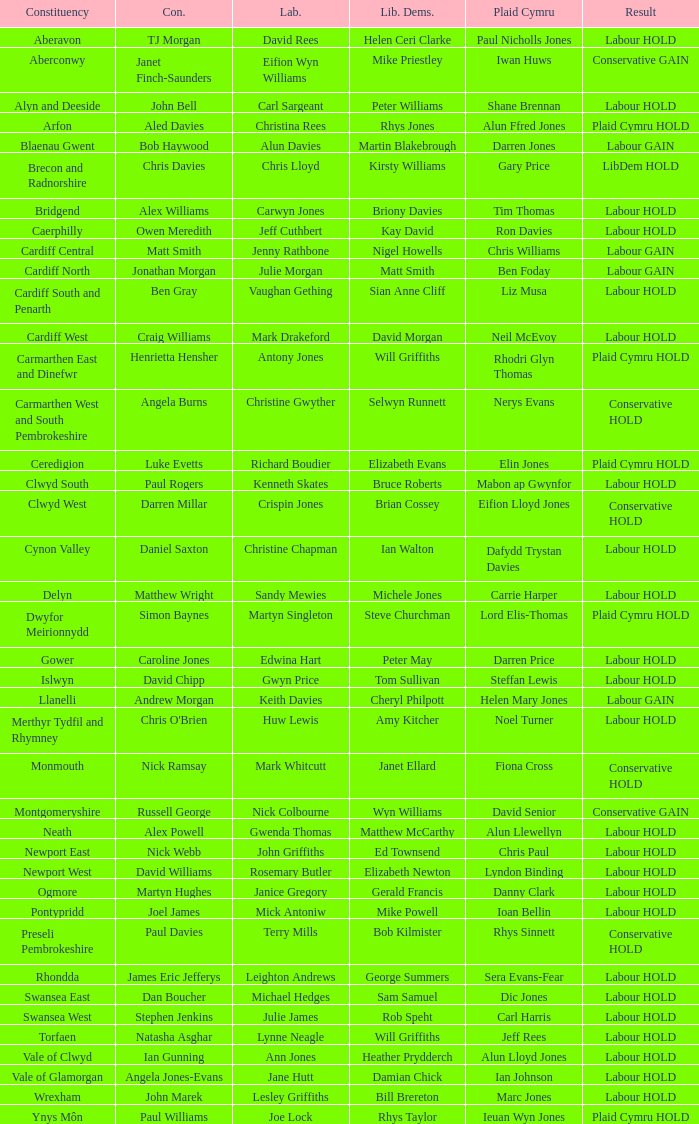In what constituency was the result labour hold and Liberal democrat Elizabeth Newton won? Newport West. 